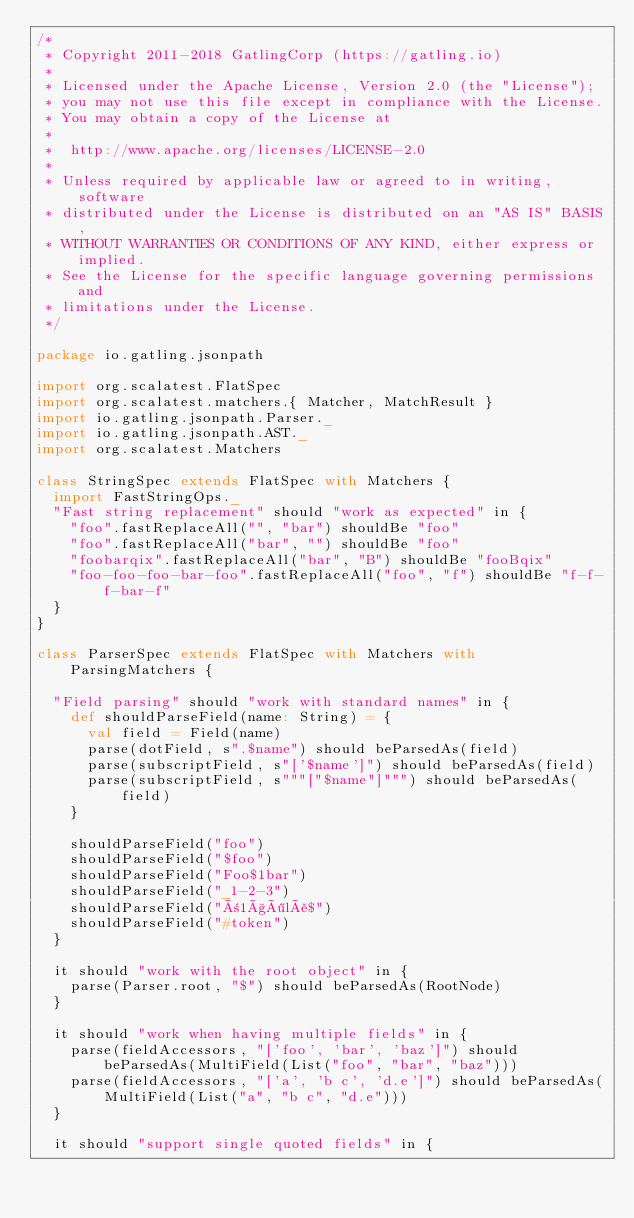<code> <loc_0><loc_0><loc_500><loc_500><_Scala_>/*
 * Copyright 2011-2018 GatlingCorp (https://gatling.io)
 *
 * Licensed under the Apache License, Version 2.0 (the "License");
 * you may not use this file except in compliance with the License.
 * You may obtain a copy of the License at
 *
 *  http://www.apache.org/licenses/LICENSE-2.0
 *
 * Unless required by applicable law or agreed to in writing, software
 * distributed under the License is distributed on an "AS IS" BASIS,
 * WITHOUT WARRANTIES OR CONDITIONS OF ANY KIND, either express or implied.
 * See the License for the specific language governing permissions and
 * limitations under the License.
 */

package io.gatling.jsonpath

import org.scalatest.FlatSpec
import org.scalatest.matchers.{ Matcher, MatchResult }
import io.gatling.jsonpath.Parser._
import io.gatling.jsonpath.AST._
import org.scalatest.Matchers

class StringSpec extends FlatSpec with Matchers {
  import FastStringOps._
  "Fast string replacement" should "work as expected" in {
    "foo".fastReplaceAll("", "bar") shouldBe "foo"
    "foo".fastReplaceAll("bar", "") shouldBe "foo"
    "foobarqix".fastReplaceAll("bar", "B") shouldBe "fooBqix"
    "foo-foo-foo-bar-foo".fastReplaceAll("foo", "f") shouldBe "f-f-f-bar-f"
  }
}

class ParserSpec extends FlatSpec with Matchers with ParsingMatchers {

  "Field parsing" should "work with standard names" in {
    def shouldParseField(name: String) = {
      val field = Field(name)
      parse(dotField, s".$name") should beParsedAs(field)
      parse(subscriptField, s"['$name']") should beParsedAs(field)
      parse(subscriptField, s"""["$name"]""") should beParsedAs(field)
    }

    shouldParseField("foo")
    shouldParseField("$foo")
    shouldParseField("Foo$1bar")
    shouldParseField("_1-2-3")
    shouldParseField("ñ1çölå$")
    shouldParseField("#token")
  }

  it should "work with the root object" in {
    parse(Parser.root, "$") should beParsedAs(RootNode)
  }

  it should "work when having multiple fields" in {
    parse(fieldAccessors, "['foo', 'bar', 'baz']") should beParsedAs(MultiField(List("foo", "bar", "baz")))
    parse(fieldAccessors, "['a', 'b c', 'd.e']") should beParsedAs(MultiField(List("a", "b c", "d.e")))
  }

  it should "support single quoted fields" in {</code> 